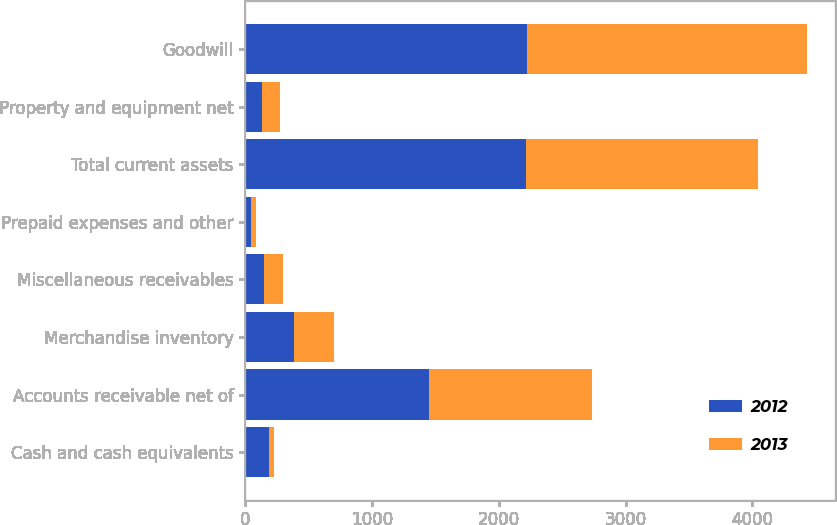Convert chart to OTSL. <chart><loc_0><loc_0><loc_500><loc_500><stacked_bar_chart><ecel><fcel>Cash and cash equivalents<fcel>Accounts receivable net of<fcel>Merchandise inventory<fcel>Miscellaneous receivables<fcel>Prepaid expenses and other<fcel>Total current assets<fcel>Property and equipment net<fcel>Goodwill<nl><fcel>2012<fcel>188.1<fcel>1451<fcel>382<fcel>146.3<fcel>46.1<fcel>2213.5<fcel>131.1<fcel>2220.3<nl><fcel>2013<fcel>37.9<fcel>1285<fcel>314.6<fcel>148.5<fcel>34.6<fcel>1834.7<fcel>142.7<fcel>2209.3<nl></chart> 